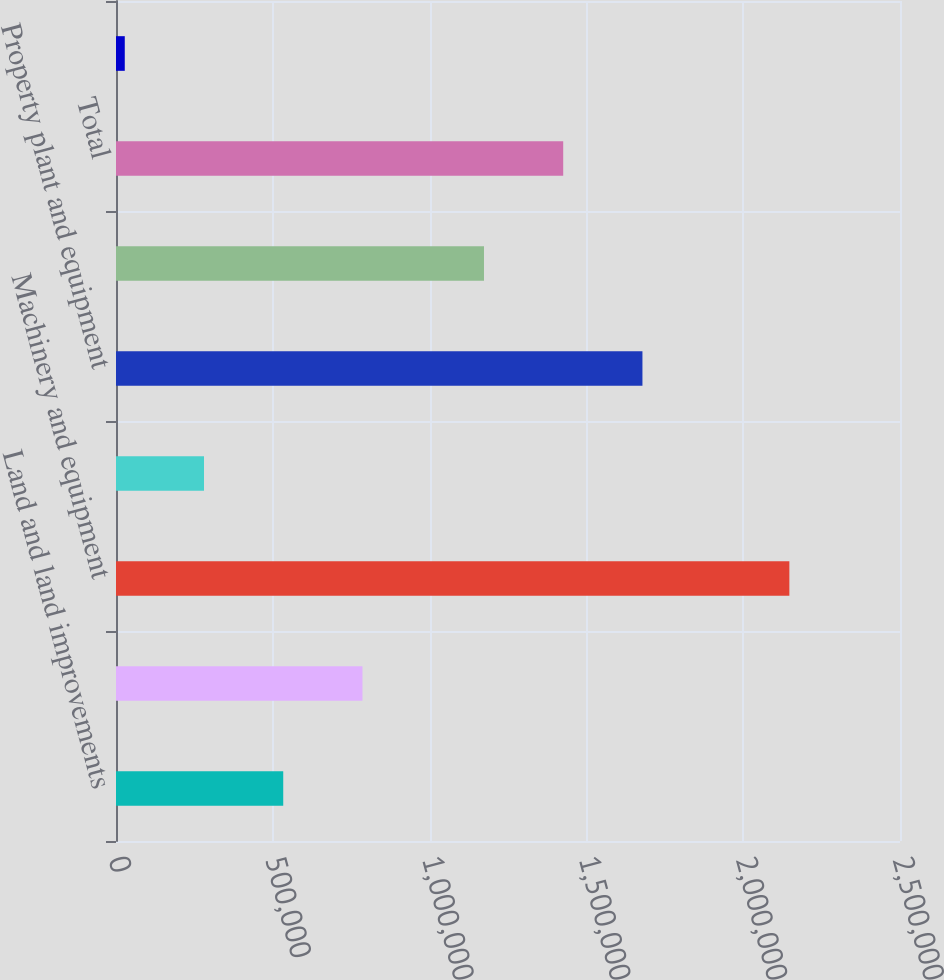Convert chart to OTSL. <chart><loc_0><loc_0><loc_500><loc_500><bar_chart><fcel>Land and land improvements<fcel>Buildings<fcel>Machinery and equipment<fcel>Other<fcel>Property plant and equipment<fcel>Less Accumulated depreciation<fcel>Total<fcel>Construction in progress<nl><fcel>533271<fcel>785914<fcel>2.14721e+06<fcel>280628<fcel>1.67871e+06<fcel>1.17342e+06<fcel>1.42606e+06<fcel>27985<nl></chart> 